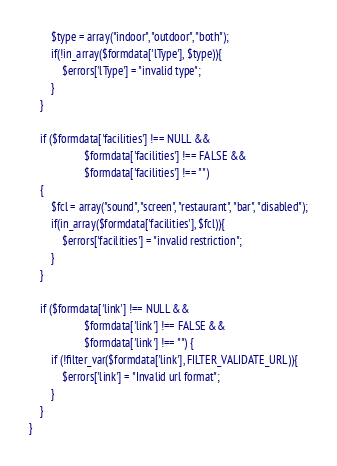Convert code to text. <code><loc_0><loc_0><loc_500><loc_500><_PHP_>        $type = array("indoor", "outdoor", "both");
        if(!in_array($formdata['lType'], $type)){
            $errors['lType'] = "invalid type";
        }
    }
    
    if ($formdata['facilities'] !== NULL &&
                    $formdata['facilities'] !== FALSE &&
                    $formdata['facilities'] !== "")
    {
        $fcl = array("sound", "screen", "restaurant", "bar", "disabled");
        if(in_array($formdata['facilities'], $fcl)){
            $errors['facilities'] = "invalid restriction";
        }
    }
    
    if ($formdata['link'] !== NULL &&
                    $formdata['link'] !== FALSE &&
                    $formdata['link'] !== "") {
        if (!filter_var($formdata['link'], FILTER_VALIDATE_URL)){
            $errors['link'] = "Invalid url format";
        }
    }
}
</code> 